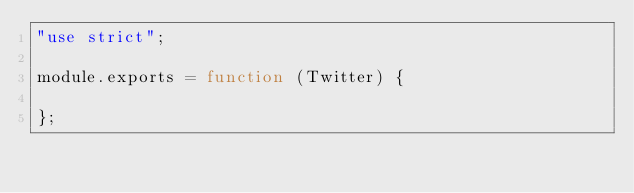Convert code to text. <code><loc_0><loc_0><loc_500><loc_500><_JavaScript_>"use strict";

module.exports = function (Twitter) {

};
</code> 